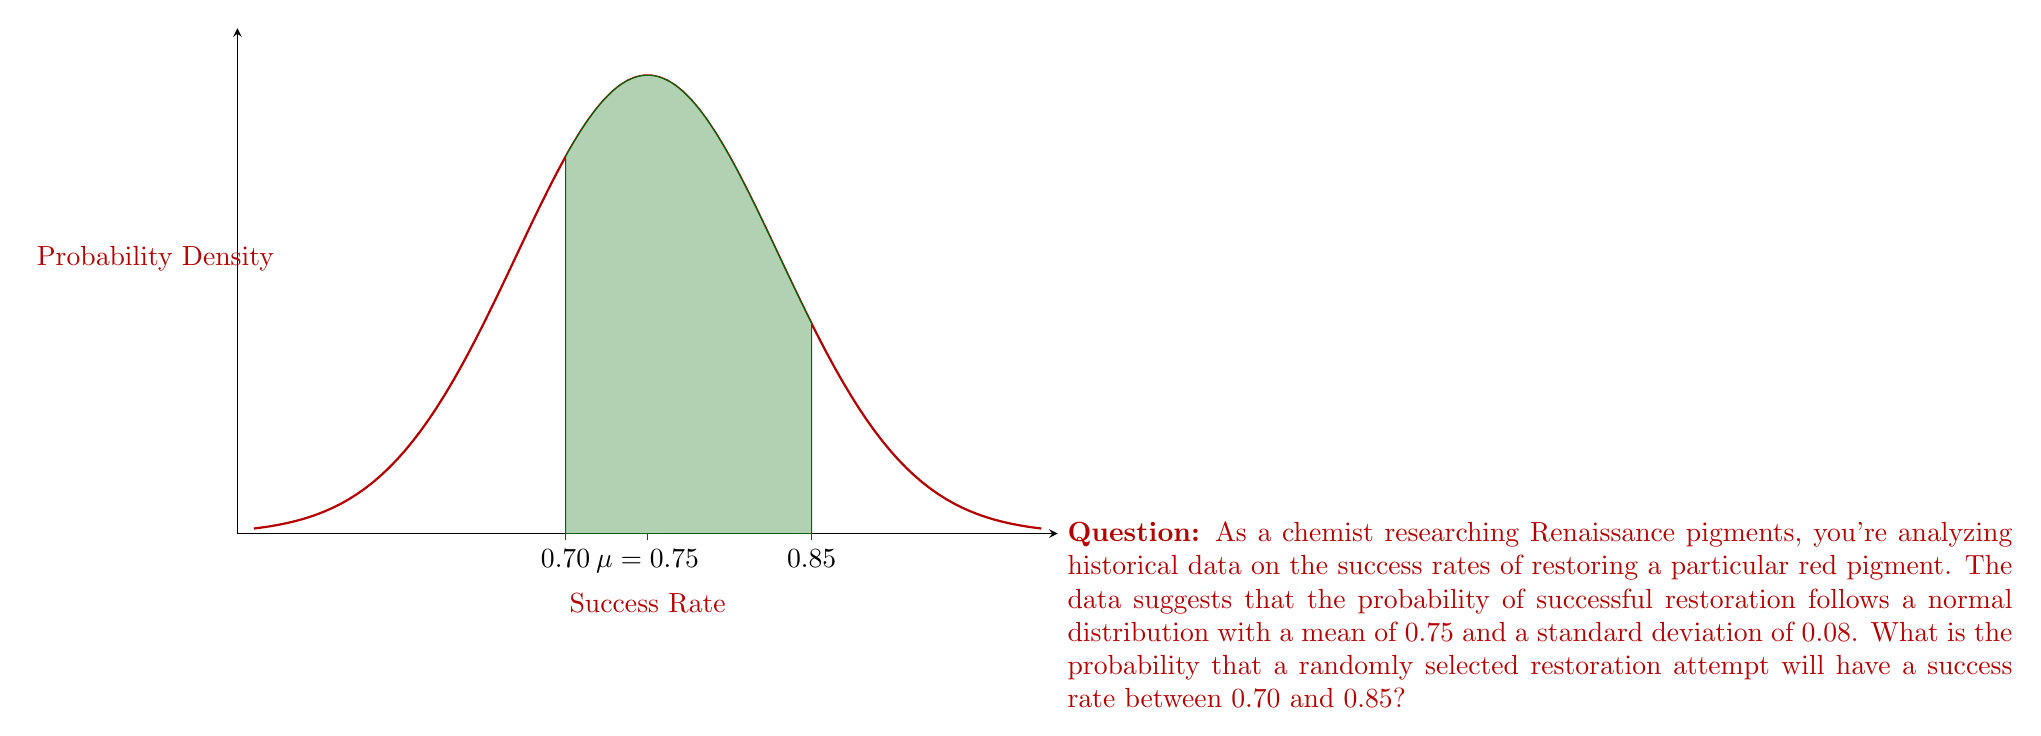Can you answer this question? To solve this problem, we need to use the properties of the normal distribution and the concept of z-scores. Let's approach this step-by-step:

1) We are given that the success rate follows a normal distribution with:
   $\mu = 0.75$ (mean)
   $\sigma = 0.08$ (standard deviation)

2) We need to find the probability that a randomly selected restoration attempt will have a success rate between 0.70 and 0.85.

3) First, let's calculate the z-scores for both boundaries:

   For 0.70: $z_1 = \frac{0.70 - 0.75}{0.08} = -0.625$
   For 0.85: $z_2 = \frac{0.85 - 0.75}{0.08} = 1.25$

4) Now, we need to find the area under the standard normal curve between these two z-scores.

5) We can use the standard normal cumulative distribution function (often denoted as $\Phi(z)$) to find this probability:

   $P(0.70 < X < 0.85) = \Phi(1.25) - \Phi(-0.625)$

6) Using a standard normal table or calculator:

   $\Phi(1.25) \approx 0.8944$
   $\Phi(-0.625) \approx 0.2660$

7) Therefore, the probability is:

   $P(0.70 < X < 0.85) = 0.8944 - 0.2660 = 0.6284$

Thus, there is approximately a 62.84% chance that a randomly selected restoration attempt will have a success rate between 0.70 and 0.85.
Answer: 0.6284 or 62.84% 